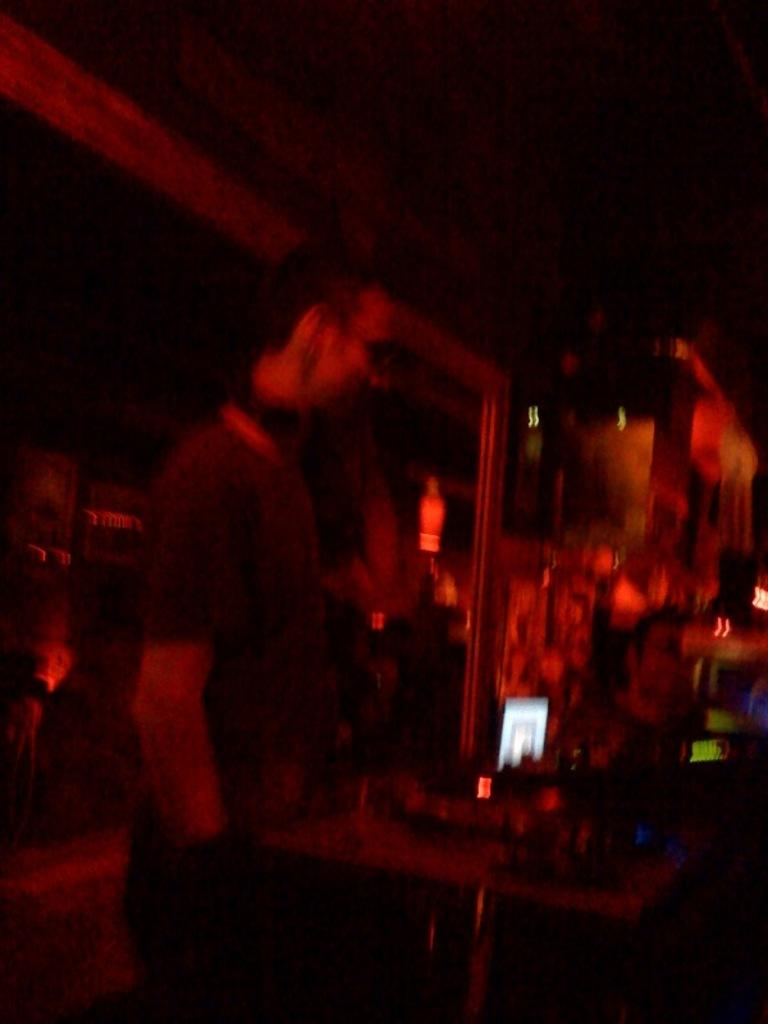Who or what can be seen in the image? There are persons in the image. What type of furniture is present in the image? There are tables in the image. What else can be observed in the image besides the persons and tables? There are objects in the image. Can you describe the lighting or setting of the image? The image is set in a dark place. Reasoning: Let' Let's think step by step in order to produce the conversation. We start by identifying the main subjects in the image, which are the persons. Then, we expand the conversation to include other elements of the image, such as the tables and objects. Finally, we describe the setting or lighting of the image, which is dark. Absurd Question/Answer: What arithmetic problem is being solved on the table in the image? There is no arithmetic problem visible in the image. Can you tell me which account the persons in the image are discussing? There is no mention of an account or any financial discussion in the image. What type of border is visible in the image? There is no border visible in the image. 